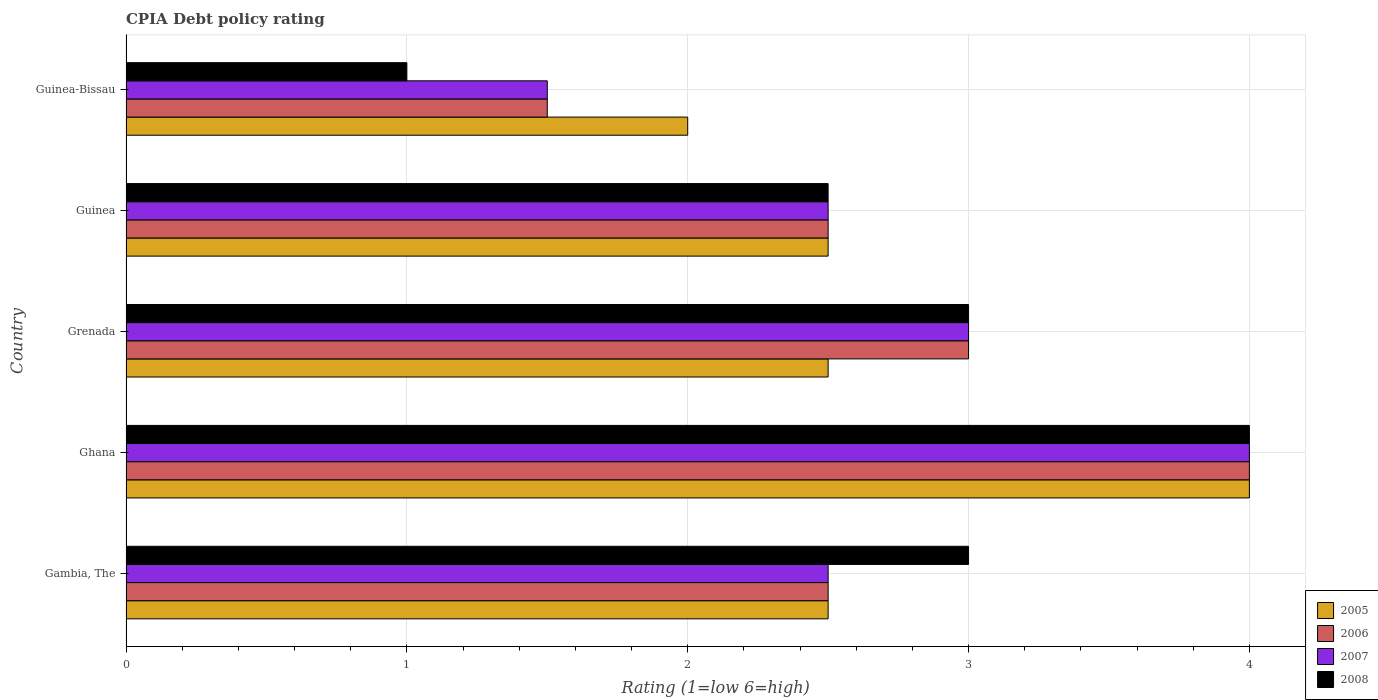How many groups of bars are there?
Make the answer very short. 5. Are the number of bars per tick equal to the number of legend labels?
Offer a very short reply. Yes. What is the label of the 3rd group of bars from the top?
Provide a succinct answer. Grenada. Across all countries, what is the maximum CPIA rating in 2005?
Offer a terse response. 4. Across all countries, what is the minimum CPIA rating in 2006?
Offer a very short reply. 1.5. In which country was the CPIA rating in 2007 maximum?
Your answer should be compact. Ghana. In which country was the CPIA rating in 2008 minimum?
Give a very brief answer. Guinea-Bissau. What is the difference between the CPIA rating in 2006 in Grenada and that in Guinea?
Offer a terse response. 0.5. What is the average CPIA rating in 2007 per country?
Your answer should be very brief. 2.7. In how many countries, is the CPIA rating in 2006 greater than 1.2 ?
Offer a very short reply. 5. Is the CPIA rating in 2005 in Guinea less than that in Guinea-Bissau?
Your answer should be compact. No. Is the difference between the CPIA rating in 2007 in Gambia, The and Grenada greater than the difference between the CPIA rating in 2008 in Gambia, The and Grenada?
Offer a terse response. No. What is the difference between the highest and the second highest CPIA rating in 2005?
Offer a terse response. 1.5. In how many countries, is the CPIA rating in 2008 greater than the average CPIA rating in 2008 taken over all countries?
Make the answer very short. 3. Is the sum of the CPIA rating in 2007 in Grenada and Guinea greater than the maximum CPIA rating in 2005 across all countries?
Provide a succinct answer. Yes. What does the 1st bar from the top in Guinea represents?
Ensure brevity in your answer.  2008. What does the 3rd bar from the bottom in Guinea-Bissau represents?
Keep it short and to the point. 2007. How many bars are there?
Your answer should be very brief. 20. Does the graph contain grids?
Provide a succinct answer. Yes. Where does the legend appear in the graph?
Your answer should be very brief. Bottom right. How many legend labels are there?
Your answer should be compact. 4. How are the legend labels stacked?
Provide a short and direct response. Vertical. What is the title of the graph?
Give a very brief answer. CPIA Debt policy rating. Does "1997" appear as one of the legend labels in the graph?
Your response must be concise. No. What is the label or title of the Y-axis?
Your answer should be very brief. Country. What is the Rating (1=low 6=high) of 2005 in Gambia, The?
Keep it short and to the point. 2.5. What is the Rating (1=low 6=high) of 2005 in Ghana?
Make the answer very short. 4. What is the Rating (1=low 6=high) in 2006 in Ghana?
Your answer should be compact. 4. What is the Rating (1=low 6=high) in 2007 in Ghana?
Make the answer very short. 4. What is the Rating (1=low 6=high) in 2005 in Guinea?
Provide a succinct answer. 2.5. What is the Rating (1=low 6=high) in 2006 in Guinea?
Provide a short and direct response. 2.5. What is the Rating (1=low 6=high) of 2007 in Guinea?
Provide a succinct answer. 2.5. What is the Rating (1=low 6=high) in 2005 in Guinea-Bissau?
Your answer should be compact. 2. What is the Rating (1=low 6=high) of 2008 in Guinea-Bissau?
Offer a terse response. 1. Across all countries, what is the maximum Rating (1=low 6=high) of 2005?
Your answer should be compact. 4. Across all countries, what is the maximum Rating (1=low 6=high) of 2006?
Provide a succinct answer. 4. Across all countries, what is the maximum Rating (1=low 6=high) of 2008?
Provide a short and direct response. 4. Across all countries, what is the minimum Rating (1=low 6=high) in 2005?
Your response must be concise. 2. Across all countries, what is the minimum Rating (1=low 6=high) of 2007?
Ensure brevity in your answer.  1.5. What is the total Rating (1=low 6=high) of 2005 in the graph?
Keep it short and to the point. 13.5. What is the total Rating (1=low 6=high) in 2006 in the graph?
Offer a terse response. 13.5. What is the total Rating (1=low 6=high) of 2007 in the graph?
Ensure brevity in your answer.  13.5. What is the difference between the Rating (1=low 6=high) of 2006 in Gambia, The and that in Ghana?
Ensure brevity in your answer.  -1.5. What is the difference between the Rating (1=low 6=high) in 2007 in Gambia, The and that in Ghana?
Your response must be concise. -1.5. What is the difference between the Rating (1=low 6=high) of 2005 in Gambia, The and that in Grenada?
Offer a very short reply. 0. What is the difference between the Rating (1=low 6=high) in 2006 in Gambia, The and that in Grenada?
Your answer should be compact. -0.5. What is the difference between the Rating (1=low 6=high) in 2007 in Gambia, The and that in Grenada?
Offer a terse response. -0.5. What is the difference between the Rating (1=low 6=high) in 2007 in Gambia, The and that in Guinea?
Provide a short and direct response. 0. What is the difference between the Rating (1=low 6=high) in 2008 in Gambia, The and that in Guinea?
Your answer should be very brief. 0.5. What is the difference between the Rating (1=low 6=high) in 2005 in Gambia, The and that in Guinea-Bissau?
Give a very brief answer. 0.5. What is the difference between the Rating (1=low 6=high) of 2007 in Gambia, The and that in Guinea-Bissau?
Provide a short and direct response. 1. What is the difference between the Rating (1=low 6=high) of 2005 in Ghana and that in Grenada?
Your response must be concise. 1.5. What is the difference between the Rating (1=low 6=high) of 2006 in Ghana and that in Grenada?
Provide a succinct answer. 1. What is the difference between the Rating (1=low 6=high) of 2007 in Ghana and that in Grenada?
Provide a short and direct response. 1. What is the difference between the Rating (1=low 6=high) of 2008 in Ghana and that in Grenada?
Make the answer very short. 1. What is the difference between the Rating (1=low 6=high) of 2005 in Ghana and that in Guinea?
Provide a succinct answer. 1.5. What is the difference between the Rating (1=low 6=high) of 2006 in Ghana and that in Guinea?
Ensure brevity in your answer.  1.5. What is the difference between the Rating (1=low 6=high) in 2005 in Ghana and that in Guinea-Bissau?
Your response must be concise. 2. What is the difference between the Rating (1=low 6=high) of 2006 in Ghana and that in Guinea-Bissau?
Your answer should be very brief. 2.5. What is the difference between the Rating (1=low 6=high) in 2007 in Ghana and that in Guinea-Bissau?
Make the answer very short. 2.5. What is the difference between the Rating (1=low 6=high) of 2005 in Grenada and that in Guinea?
Keep it short and to the point. 0. What is the difference between the Rating (1=low 6=high) of 2006 in Grenada and that in Guinea?
Ensure brevity in your answer.  0.5. What is the difference between the Rating (1=low 6=high) in 2008 in Grenada and that in Guinea?
Your answer should be compact. 0.5. What is the difference between the Rating (1=low 6=high) of 2008 in Grenada and that in Guinea-Bissau?
Provide a succinct answer. 2. What is the difference between the Rating (1=low 6=high) of 2005 in Guinea and that in Guinea-Bissau?
Provide a short and direct response. 0.5. What is the difference between the Rating (1=low 6=high) in 2008 in Guinea and that in Guinea-Bissau?
Offer a very short reply. 1.5. What is the difference between the Rating (1=low 6=high) in 2005 in Gambia, The and the Rating (1=low 6=high) in 2008 in Ghana?
Offer a very short reply. -1.5. What is the difference between the Rating (1=low 6=high) in 2006 in Gambia, The and the Rating (1=low 6=high) in 2008 in Ghana?
Your answer should be compact. -1.5. What is the difference between the Rating (1=low 6=high) in 2005 in Gambia, The and the Rating (1=low 6=high) in 2008 in Grenada?
Make the answer very short. -0.5. What is the difference between the Rating (1=low 6=high) of 2006 in Gambia, The and the Rating (1=low 6=high) of 2007 in Grenada?
Give a very brief answer. -0.5. What is the difference between the Rating (1=low 6=high) in 2007 in Gambia, The and the Rating (1=low 6=high) in 2008 in Grenada?
Offer a very short reply. -0.5. What is the difference between the Rating (1=low 6=high) in 2005 in Gambia, The and the Rating (1=low 6=high) in 2006 in Guinea?
Make the answer very short. 0. What is the difference between the Rating (1=low 6=high) of 2006 in Gambia, The and the Rating (1=low 6=high) of 2007 in Guinea-Bissau?
Keep it short and to the point. 1. What is the difference between the Rating (1=low 6=high) of 2006 in Gambia, The and the Rating (1=low 6=high) of 2008 in Guinea-Bissau?
Give a very brief answer. 1.5. What is the difference between the Rating (1=low 6=high) of 2005 in Ghana and the Rating (1=low 6=high) of 2006 in Grenada?
Provide a succinct answer. 1. What is the difference between the Rating (1=low 6=high) in 2005 in Ghana and the Rating (1=low 6=high) in 2008 in Guinea?
Your answer should be very brief. 1.5. What is the difference between the Rating (1=low 6=high) of 2006 in Ghana and the Rating (1=low 6=high) of 2008 in Guinea?
Give a very brief answer. 1.5. What is the difference between the Rating (1=low 6=high) of 2007 in Ghana and the Rating (1=low 6=high) of 2008 in Guinea?
Your answer should be compact. 1.5. What is the difference between the Rating (1=low 6=high) in 2005 in Ghana and the Rating (1=low 6=high) in 2006 in Guinea-Bissau?
Keep it short and to the point. 2.5. What is the difference between the Rating (1=low 6=high) of 2006 in Ghana and the Rating (1=low 6=high) of 2007 in Guinea-Bissau?
Your answer should be compact. 2.5. What is the difference between the Rating (1=low 6=high) of 2005 in Grenada and the Rating (1=low 6=high) of 2006 in Guinea?
Provide a short and direct response. 0. What is the difference between the Rating (1=low 6=high) in 2005 in Grenada and the Rating (1=low 6=high) in 2008 in Guinea?
Your answer should be very brief. 0. What is the difference between the Rating (1=low 6=high) of 2006 in Grenada and the Rating (1=low 6=high) of 2007 in Guinea?
Offer a terse response. 0.5. What is the difference between the Rating (1=low 6=high) in 2007 in Grenada and the Rating (1=low 6=high) in 2008 in Guinea?
Your answer should be compact. 0.5. What is the difference between the Rating (1=low 6=high) in 2005 in Grenada and the Rating (1=low 6=high) in 2007 in Guinea-Bissau?
Ensure brevity in your answer.  1. What is the difference between the Rating (1=low 6=high) of 2006 in Grenada and the Rating (1=low 6=high) of 2007 in Guinea-Bissau?
Provide a succinct answer. 1.5. What is the difference between the Rating (1=low 6=high) of 2006 in Grenada and the Rating (1=low 6=high) of 2008 in Guinea-Bissau?
Provide a succinct answer. 2. What is the difference between the Rating (1=low 6=high) in 2007 in Grenada and the Rating (1=low 6=high) in 2008 in Guinea-Bissau?
Your answer should be compact. 2. What is the difference between the Rating (1=low 6=high) of 2005 in Guinea and the Rating (1=low 6=high) of 2007 in Guinea-Bissau?
Provide a succinct answer. 1. What is the difference between the Rating (1=low 6=high) of 2005 in Guinea and the Rating (1=low 6=high) of 2008 in Guinea-Bissau?
Your answer should be compact. 1.5. What is the difference between the Rating (1=low 6=high) of 2006 in Guinea and the Rating (1=low 6=high) of 2007 in Guinea-Bissau?
Give a very brief answer. 1. What is the average Rating (1=low 6=high) in 2005 per country?
Your response must be concise. 2.7. What is the average Rating (1=low 6=high) of 2007 per country?
Offer a very short reply. 2.7. What is the difference between the Rating (1=low 6=high) of 2005 and Rating (1=low 6=high) of 2006 in Gambia, The?
Provide a short and direct response. 0. What is the difference between the Rating (1=low 6=high) in 2005 and Rating (1=low 6=high) in 2007 in Gambia, The?
Provide a succinct answer. 0. What is the difference between the Rating (1=low 6=high) of 2005 and Rating (1=low 6=high) of 2008 in Gambia, The?
Your response must be concise. -0.5. What is the difference between the Rating (1=low 6=high) in 2006 and Rating (1=low 6=high) in 2008 in Gambia, The?
Keep it short and to the point. -0.5. What is the difference between the Rating (1=low 6=high) of 2007 and Rating (1=low 6=high) of 2008 in Gambia, The?
Provide a succinct answer. -0.5. What is the difference between the Rating (1=low 6=high) in 2005 and Rating (1=low 6=high) in 2007 in Ghana?
Give a very brief answer. 0. What is the difference between the Rating (1=low 6=high) of 2006 and Rating (1=low 6=high) of 2007 in Ghana?
Your answer should be compact. 0. What is the difference between the Rating (1=low 6=high) in 2005 and Rating (1=low 6=high) in 2008 in Grenada?
Offer a very short reply. -0.5. What is the difference between the Rating (1=low 6=high) in 2006 and Rating (1=low 6=high) in 2008 in Grenada?
Your response must be concise. 0. What is the difference between the Rating (1=low 6=high) of 2007 and Rating (1=low 6=high) of 2008 in Grenada?
Offer a terse response. 0. What is the difference between the Rating (1=low 6=high) of 2005 and Rating (1=low 6=high) of 2008 in Guinea?
Offer a terse response. 0. What is the difference between the Rating (1=low 6=high) of 2006 and Rating (1=low 6=high) of 2008 in Guinea?
Ensure brevity in your answer.  0. What is the difference between the Rating (1=low 6=high) in 2005 and Rating (1=low 6=high) in 2006 in Guinea-Bissau?
Your response must be concise. 0.5. What is the difference between the Rating (1=low 6=high) of 2005 and Rating (1=low 6=high) of 2007 in Guinea-Bissau?
Provide a succinct answer. 0.5. What is the difference between the Rating (1=low 6=high) in 2005 and Rating (1=low 6=high) in 2008 in Guinea-Bissau?
Provide a succinct answer. 1. What is the difference between the Rating (1=low 6=high) in 2006 and Rating (1=low 6=high) in 2008 in Guinea-Bissau?
Make the answer very short. 0.5. What is the difference between the Rating (1=low 6=high) in 2007 and Rating (1=low 6=high) in 2008 in Guinea-Bissau?
Offer a terse response. 0.5. What is the ratio of the Rating (1=low 6=high) of 2005 in Gambia, The to that in Ghana?
Offer a very short reply. 0.62. What is the ratio of the Rating (1=low 6=high) in 2008 in Gambia, The to that in Ghana?
Offer a terse response. 0.75. What is the ratio of the Rating (1=low 6=high) of 2005 in Gambia, The to that in Grenada?
Ensure brevity in your answer.  1. What is the ratio of the Rating (1=low 6=high) in 2006 in Gambia, The to that in Grenada?
Ensure brevity in your answer.  0.83. What is the ratio of the Rating (1=low 6=high) in 2008 in Gambia, The to that in Grenada?
Provide a succinct answer. 1. What is the ratio of the Rating (1=low 6=high) in 2006 in Gambia, The to that in Guinea?
Ensure brevity in your answer.  1. What is the ratio of the Rating (1=low 6=high) in 2007 in Gambia, The to that in Guinea?
Ensure brevity in your answer.  1. What is the ratio of the Rating (1=low 6=high) in 2008 in Gambia, The to that in Guinea?
Your answer should be compact. 1.2. What is the ratio of the Rating (1=low 6=high) of 2006 in Gambia, The to that in Guinea-Bissau?
Provide a short and direct response. 1.67. What is the ratio of the Rating (1=low 6=high) in 2008 in Gambia, The to that in Guinea-Bissau?
Ensure brevity in your answer.  3. What is the ratio of the Rating (1=low 6=high) in 2005 in Ghana to that in Grenada?
Keep it short and to the point. 1.6. What is the ratio of the Rating (1=low 6=high) in 2006 in Ghana to that in Grenada?
Your answer should be compact. 1.33. What is the ratio of the Rating (1=low 6=high) of 2007 in Ghana to that in Grenada?
Offer a terse response. 1.33. What is the ratio of the Rating (1=low 6=high) of 2008 in Ghana to that in Grenada?
Your answer should be compact. 1.33. What is the ratio of the Rating (1=low 6=high) of 2007 in Ghana to that in Guinea?
Your answer should be compact. 1.6. What is the ratio of the Rating (1=low 6=high) of 2008 in Ghana to that in Guinea?
Offer a very short reply. 1.6. What is the ratio of the Rating (1=low 6=high) of 2005 in Ghana to that in Guinea-Bissau?
Your answer should be very brief. 2. What is the ratio of the Rating (1=low 6=high) of 2006 in Ghana to that in Guinea-Bissau?
Provide a short and direct response. 2.67. What is the ratio of the Rating (1=low 6=high) of 2007 in Ghana to that in Guinea-Bissau?
Provide a succinct answer. 2.67. What is the ratio of the Rating (1=low 6=high) of 2008 in Ghana to that in Guinea-Bissau?
Give a very brief answer. 4. What is the ratio of the Rating (1=low 6=high) in 2008 in Grenada to that in Guinea?
Offer a very short reply. 1.2. What is the ratio of the Rating (1=low 6=high) in 2008 in Grenada to that in Guinea-Bissau?
Your answer should be compact. 3. What is the ratio of the Rating (1=low 6=high) of 2006 in Guinea to that in Guinea-Bissau?
Offer a terse response. 1.67. What is the ratio of the Rating (1=low 6=high) of 2007 in Guinea to that in Guinea-Bissau?
Your answer should be compact. 1.67. What is the difference between the highest and the second highest Rating (1=low 6=high) in 2006?
Your response must be concise. 1. What is the difference between the highest and the second highest Rating (1=low 6=high) of 2007?
Provide a short and direct response. 1. What is the difference between the highest and the second highest Rating (1=low 6=high) of 2008?
Keep it short and to the point. 1. What is the difference between the highest and the lowest Rating (1=low 6=high) of 2007?
Ensure brevity in your answer.  2.5. What is the difference between the highest and the lowest Rating (1=low 6=high) of 2008?
Provide a succinct answer. 3. 